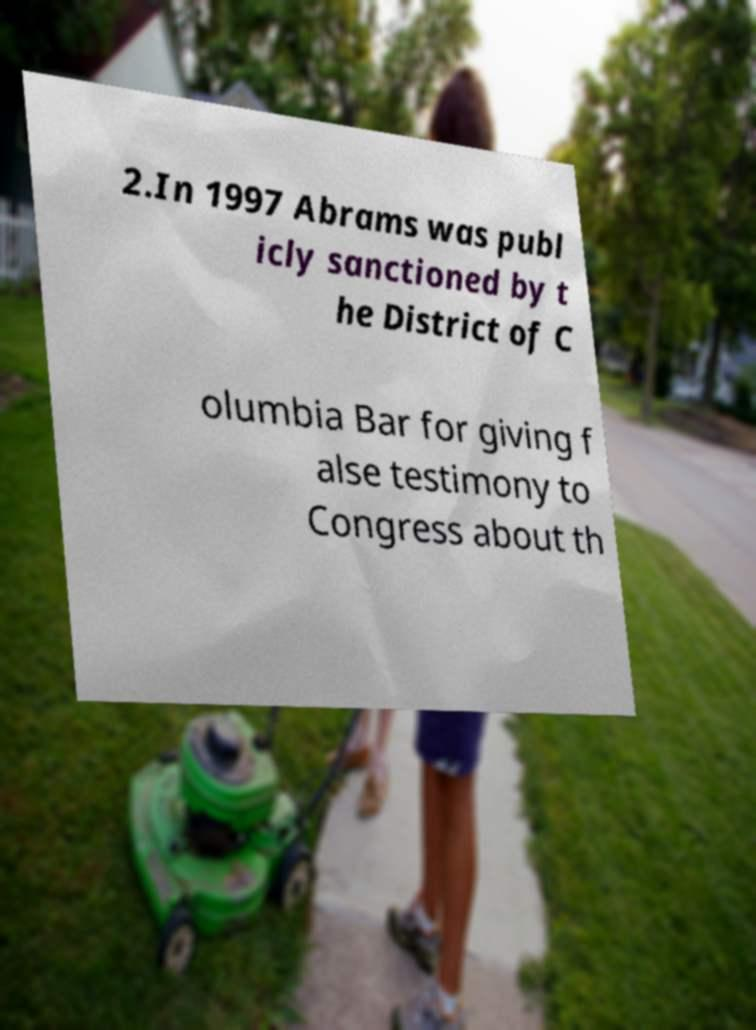Could you assist in decoding the text presented in this image and type it out clearly? 2.In 1997 Abrams was publ icly sanctioned by t he District of C olumbia Bar for giving f alse testimony to Congress about th 